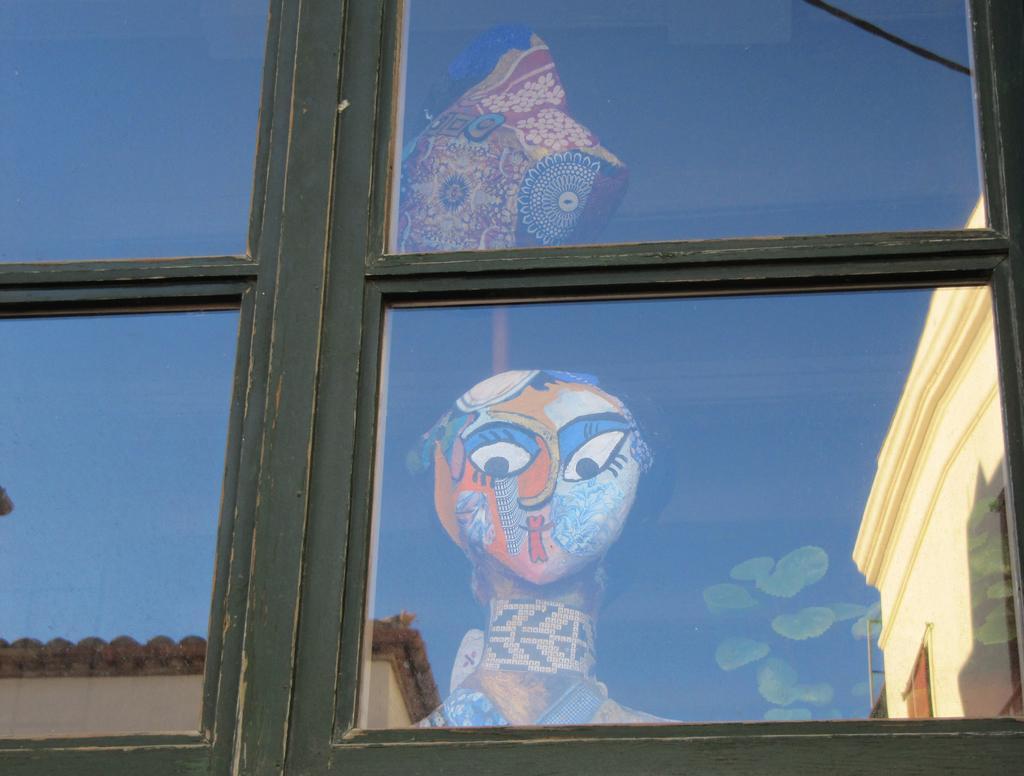Please provide a concise description of this image. In this image, we can see a glass window. In the glass window, we can see a building and a toy. On the right side of the glass window, we can also see another building and a plant. 